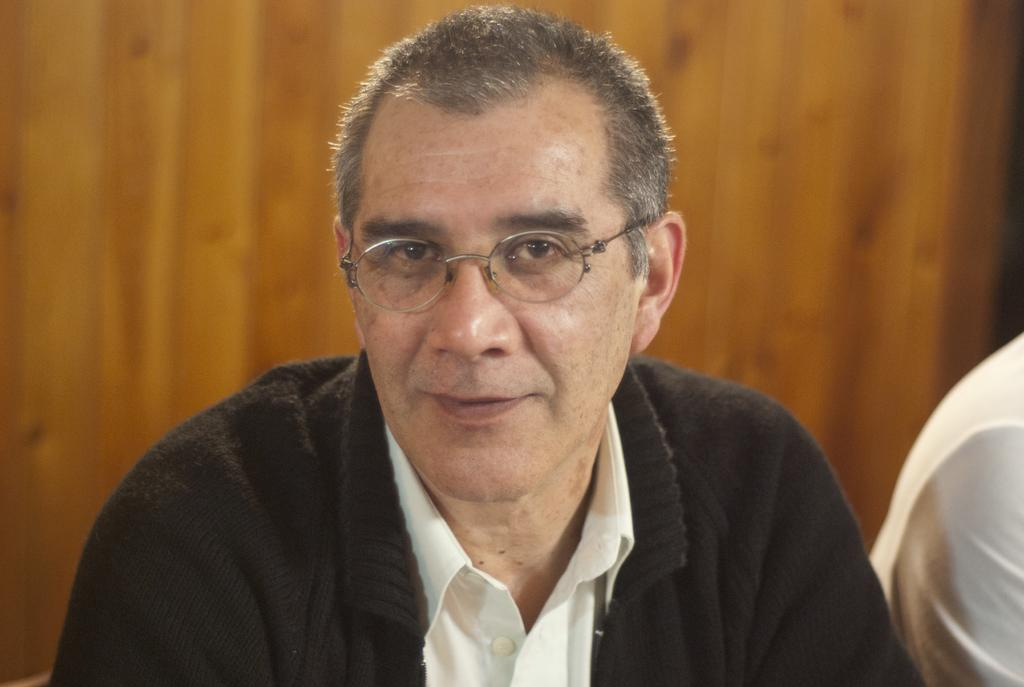How many people are in the image? There are two people in the image. Can you describe the relationship between the two people? The facts do not provide enough information to determine the relationship between the two people. What can be seen in the background of the image? There is a wooden wall in the background of the image. What type of animals can be seen performing at the show in the image? There is no show or animals present in the image; it features two people and a wooden wall in the background. 